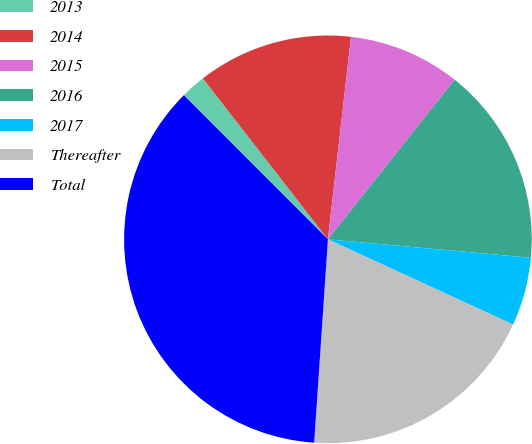Convert chart to OTSL. <chart><loc_0><loc_0><loc_500><loc_500><pie_chart><fcel>2013<fcel>2014<fcel>2015<fcel>2016<fcel>2017<fcel>Thereafter<fcel>Total<nl><fcel>1.98%<fcel>12.32%<fcel>8.87%<fcel>15.76%<fcel>5.43%<fcel>19.21%<fcel>36.43%<nl></chart> 